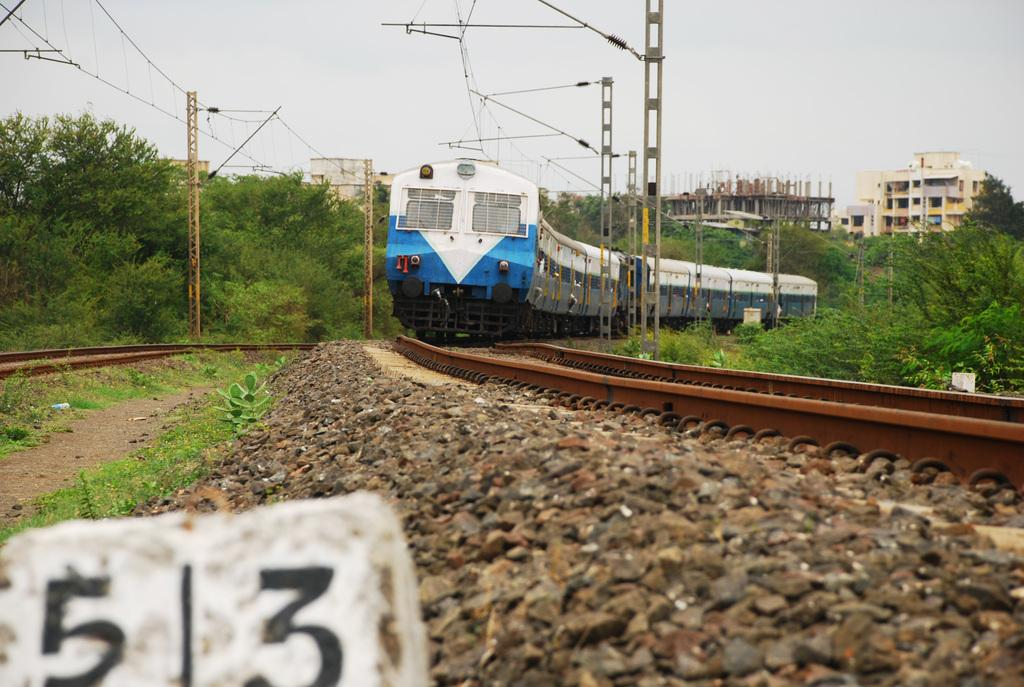<image>
Create a compact narrative representing the image presented. the numbers 5 and 3 are on a gray stone 